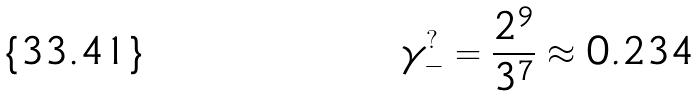<formula> <loc_0><loc_0><loc_500><loc_500>\gamma _ { - } ^ { ? } = \frac { 2 ^ { 9 } } { 3 ^ { 7 } } \approx 0 . 2 3 4</formula> 